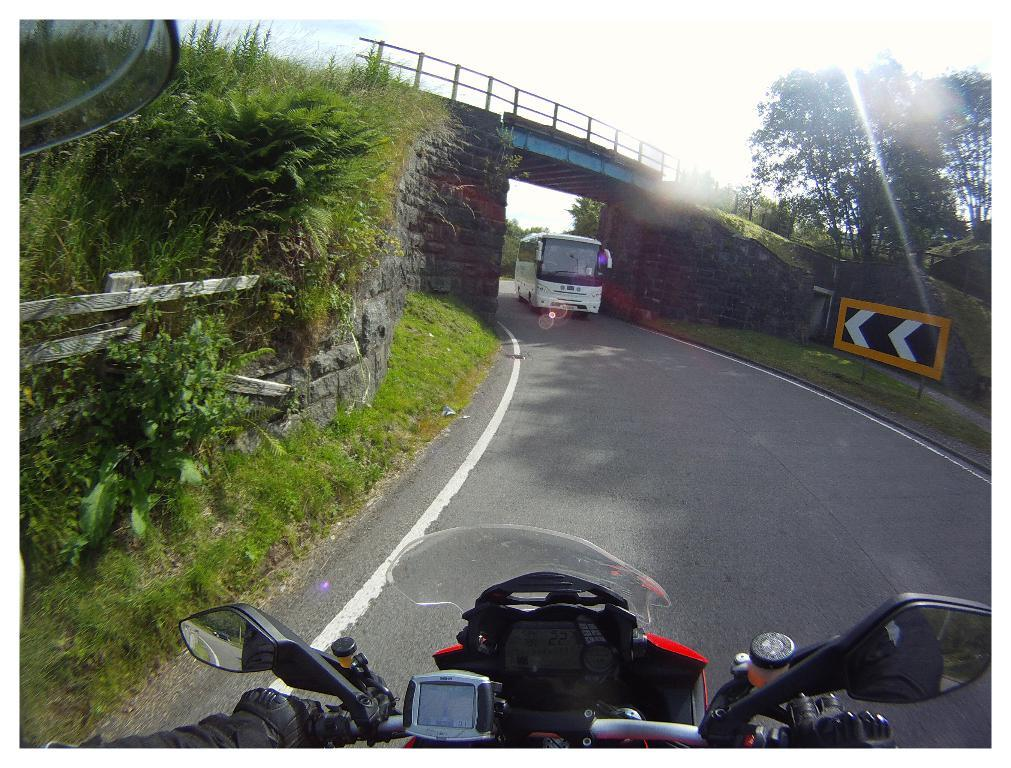What can be seen on the road in the image? There are vehicles on the road in the image. What type of natural elements are visible in the background of the image? There is grass, plants, trees, and the sky visible in the background of the image. What type of man-made structure can be seen in the background of the image? There is a bridge in the background of the image. What type of informational sign is present in the background of the image? There is a sign board in the background of the image. Can you describe the overall setting of the image? The image features vehicles on a road, with a variety of natural and man-made elements in the background, including grass, plants, trees, a bridge, a sign board, and the sky. How many ants can be seen crawling on the vehicles in the image? There are no ants visible in the image; it features vehicles on a road with various background elements. What type of wave is depicted in the image? There is no wave present in the image; it features vehicles on a road with various background elements. 